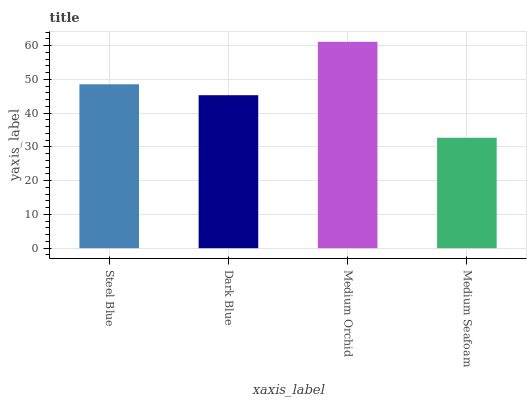Is Medium Seafoam the minimum?
Answer yes or no. Yes. Is Medium Orchid the maximum?
Answer yes or no. Yes. Is Dark Blue the minimum?
Answer yes or no. No. Is Dark Blue the maximum?
Answer yes or no. No. Is Steel Blue greater than Dark Blue?
Answer yes or no. Yes. Is Dark Blue less than Steel Blue?
Answer yes or no. Yes. Is Dark Blue greater than Steel Blue?
Answer yes or no. No. Is Steel Blue less than Dark Blue?
Answer yes or no. No. Is Steel Blue the high median?
Answer yes or no. Yes. Is Dark Blue the low median?
Answer yes or no. Yes. Is Medium Orchid the high median?
Answer yes or no. No. Is Medium Orchid the low median?
Answer yes or no. No. 